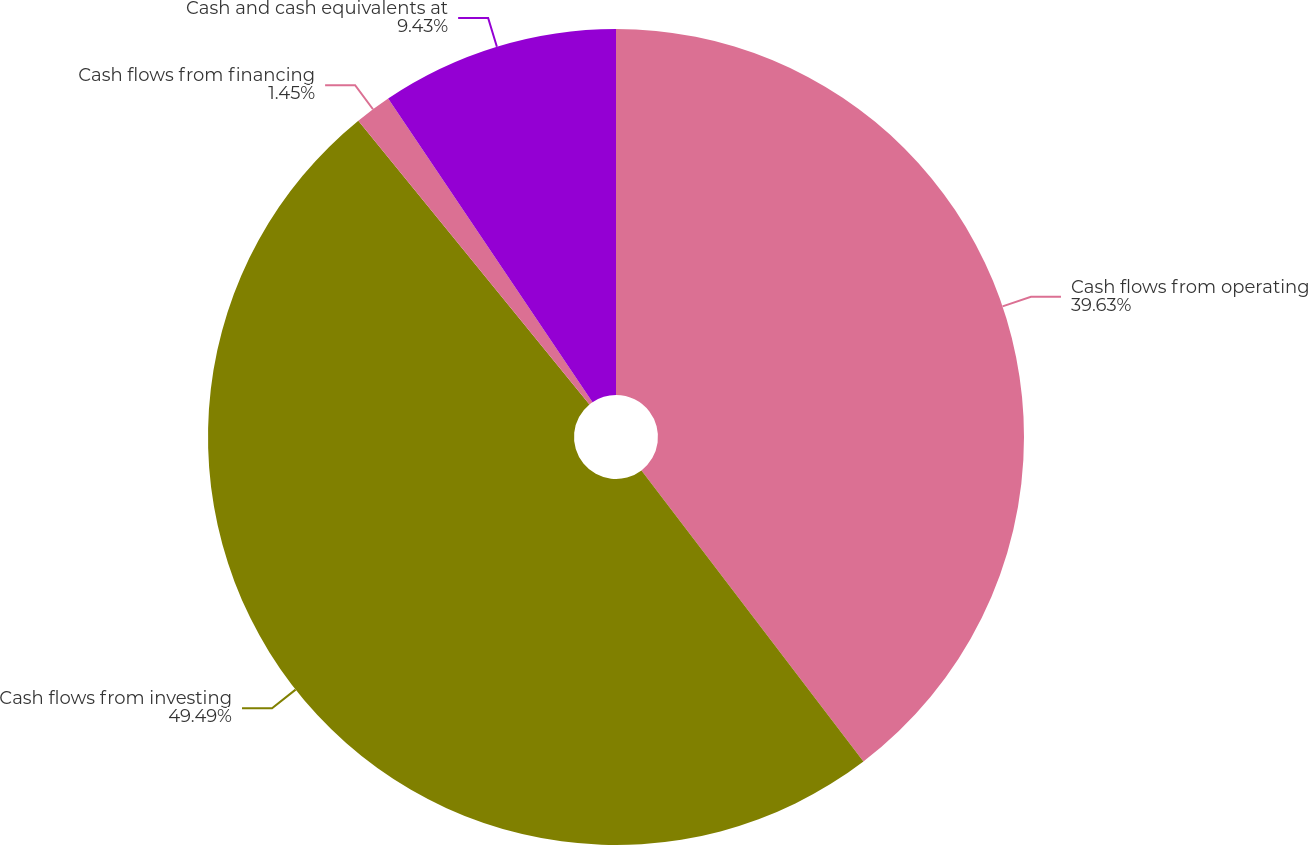Convert chart. <chart><loc_0><loc_0><loc_500><loc_500><pie_chart><fcel>Cash flows from operating<fcel>Cash flows from investing<fcel>Cash flows from financing<fcel>Cash and cash equivalents at<nl><fcel>39.63%<fcel>49.49%<fcel>1.45%<fcel>9.43%<nl></chart> 